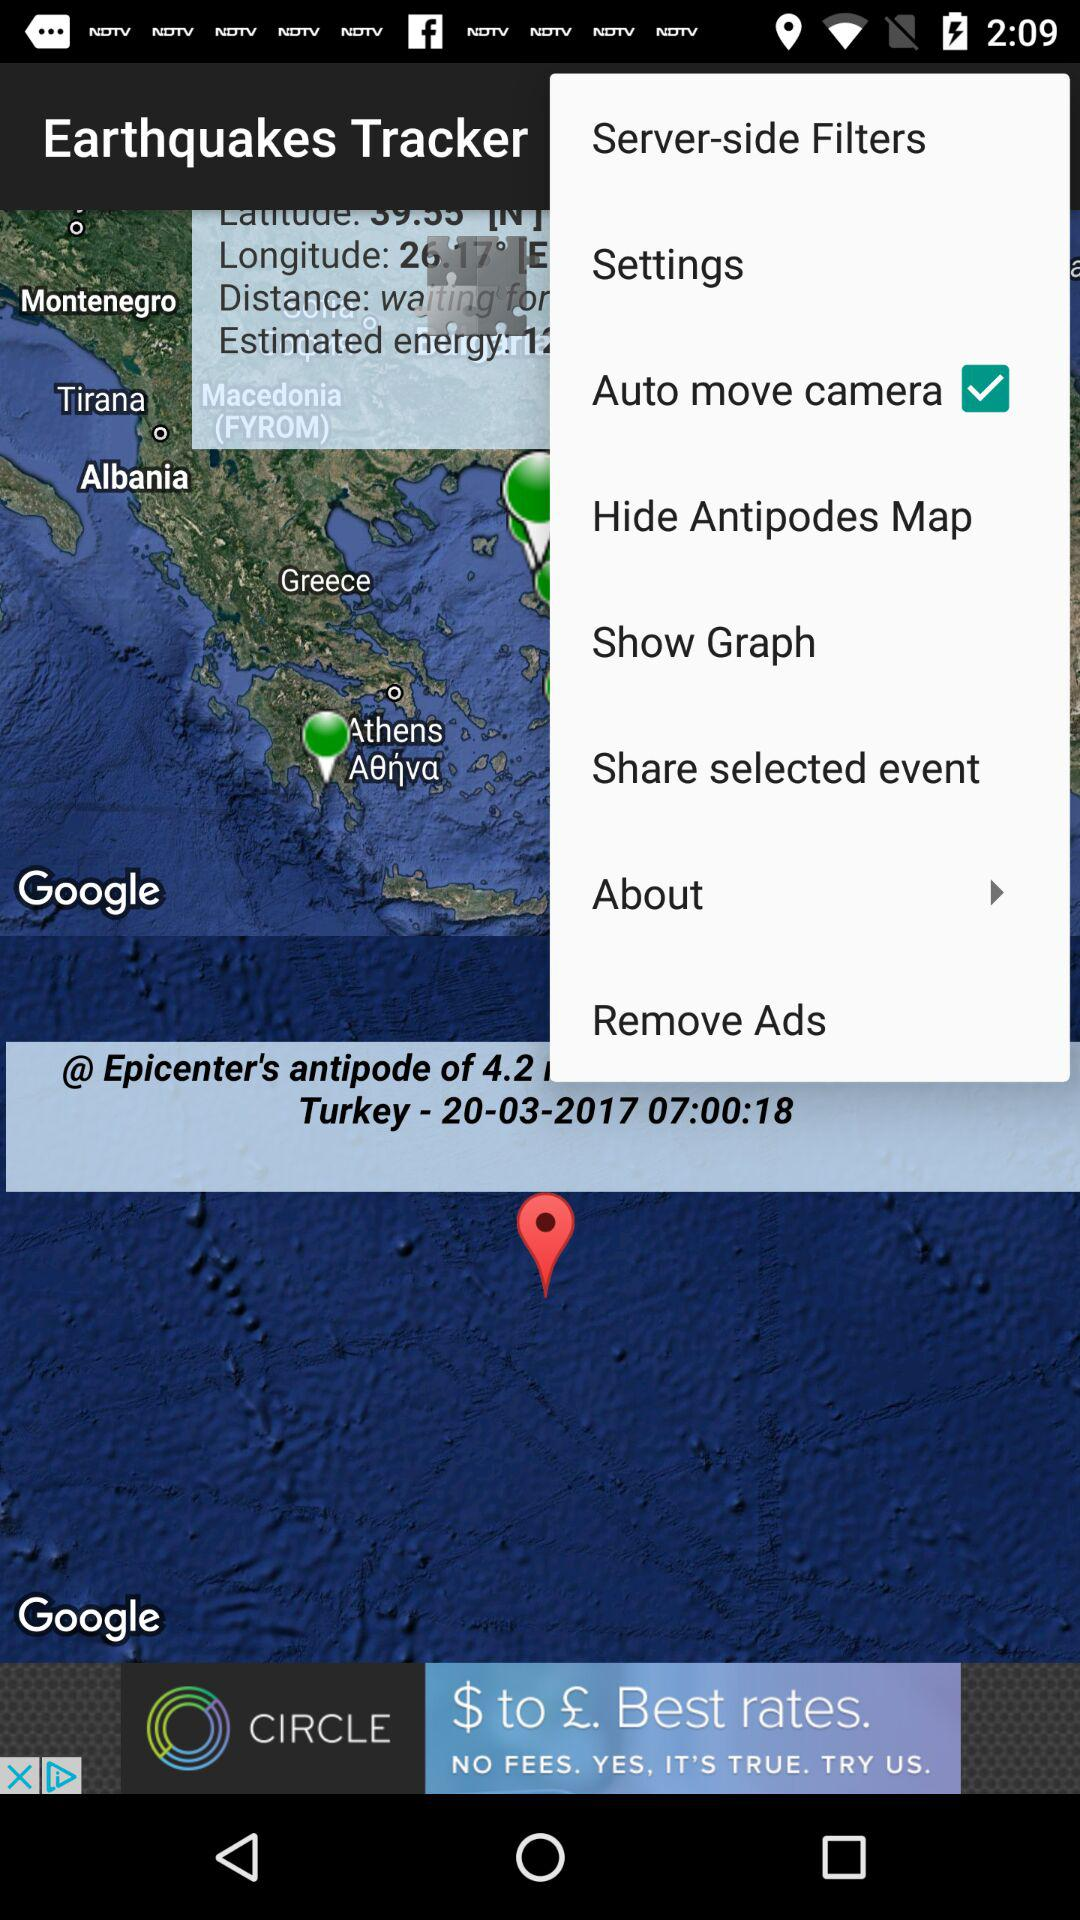What is the mentioned date? The mentioned date is March 03, 2017. 